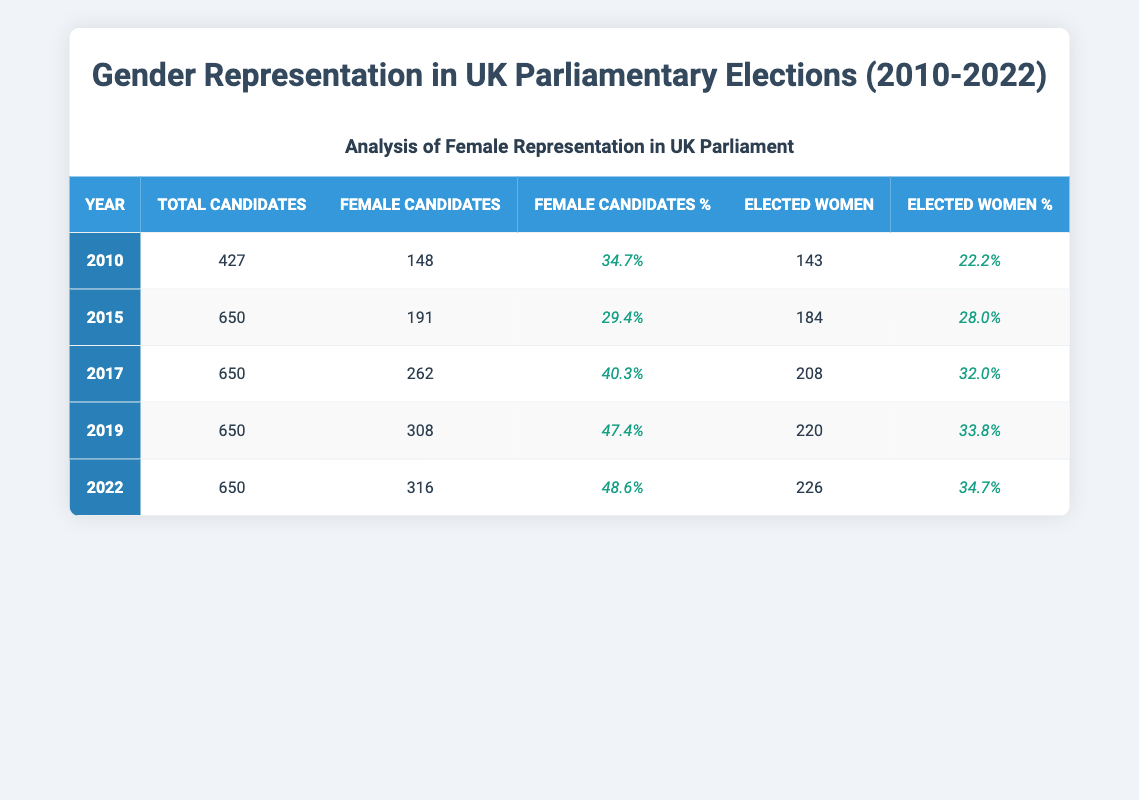What was the percentage of female candidates in the 2017 elections? The table shows that in 2017, the female candidate percentage was explicitly listed as 40.3%.
Answer: 40.3% How many total candidates were there in 2010? By directly referencing the table, the number of total candidates for the year 2010 is stated as 427.
Answer: 427 In which year did the UK see the highest number of female candidates? Comparing the female candidates across the years, 2019 has the highest number with 308 female candidates.
Answer: 2019 What is the difference in the number of elected women between 2010 and 2022? In 2010, 143 women were elected, and in 2022, 226 were elected. The difference is 226 - 143 = 83.
Answer: 83 True or False: The percentage of elected women was higher in 2015 than in 2022. Looking at the table, the elected women percentage in 2015 is 28.0% and in 2022 is 34.7%. Since 28.0% is less than 34.7%, the statement is false.
Answer: False What was the overall average percentage of female candidates from 2010 to 2022? To find the average, add the percentages of female candidates for each year: 34.7 + 29.4 + 40.3 + 47.4 + 48.6 = 200.4 and then divide by 5 (the number of years) to get 200.4 / 5 = 40.08%.
Answer: 40.08% How many female candidates were there in 2019, and what percentage does that represent of the total candidates that year? The table indicates that in 2019, there were 308 female candidates out of a total of 650 candidates. To find the percentage, calculate (308 / 650) * 100 = 47.4%.
Answer: 308 female candidates; 47.4% In which years did the percentage of female candidates exceed 40%? Reviewing the table, the years 2017 (40.3%), 2019 (47.4%), and 2022 (48.6%) all exceed 40%. Therefore, these three years are the correct answers.
Answer: 2017, 2019, 2022 